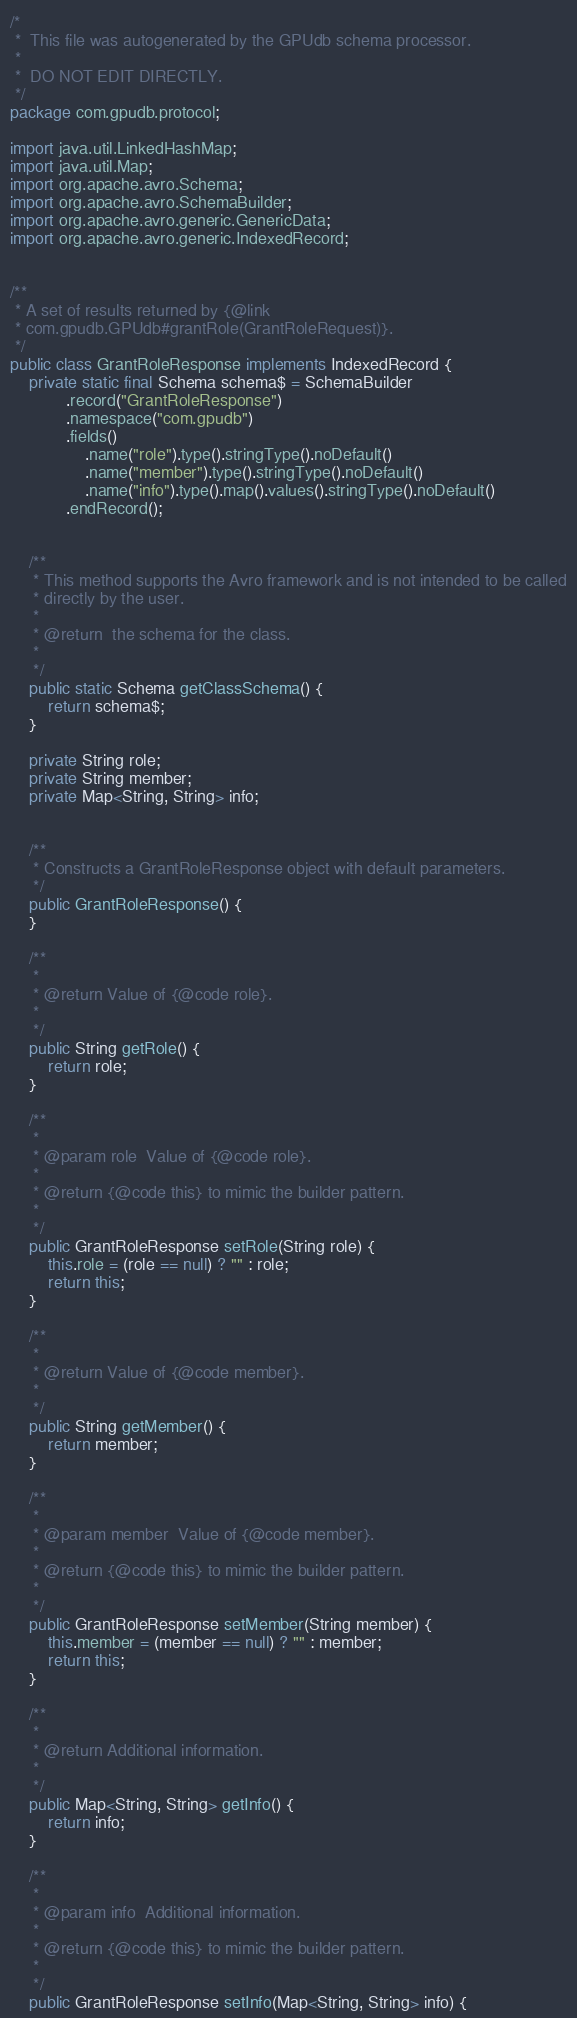Convert code to text. <code><loc_0><loc_0><loc_500><loc_500><_Java_>/*
 *  This file was autogenerated by the GPUdb schema processor.
 *
 *  DO NOT EDIT DIRECTLY.
 */
package com.gpudb.protocol;

import java.util.LinkedHashMap;
import java.util.Map;
import org.apache.avro.Schema;
import org.apache.avro.SchemaBuilder;
import org.apache.avro.generic.GenericData;
import org.apache.avro.generic.IndexedRecord;


/**
 * A set of results returned by {@link
 * com.gpudb.GPUdb#grantRole(GrantRoleRequest)}.
 */
public class GrantRoleResponse implements IndexedRecord {
    private static final Schema schema$ = SchemaBuilder
            .record("GrantRoleResponse")
            .namespace("com.gpudb")
            .fields()
                .name("role").type().stringType().noDefault()
                .name("member").type().stringType().noDefault()
                .name("info").type().map().values().stringType().noDefault()
            .endRecord();


    /**
     * This method supports the Avro framework and is not intended to be called
     * directly by the user.
     * 
     * @return  the schema for the class.
     * 
     */
    public static Schema getClassSchema() {
        return schema$;
    }

    private String role;
    private String member;
    private Map<String, String> info;


    /**
     * Constructs a GrantRoleResponse object with default parameters.
     */
    public GrantRoleResponse() {
    }

    /**
     * 
     * @return Value of {@code role}.
     * 
     */
    public String getRole() {
        return role;
    }

    /**
     * 
     * @param role  Value of {@code role}.
     * 
     * @return {@code this} to mimic the builder pattern.
     * 
     */
    public GrantRoleResponse setRole(String role) {
        this.role = (role == null) ? "" : role;
        return this;
    }

    /**
     * 
     * @return Value of {@code member}.
     * 
     */
    public String getMember() {
        return member;
    }

    /**
     * 
     * @param member  Value of {@code member}.
     * 
     * @return {@code this} to mimic the builder pattern.
     * 
     */
    public GrantRoleResponse setMember(String member) {
        this.member = (member == null) ? "" : member;
        return this;
    }

    /**
     * 
     * @return Additional information.
     * 
     */
    public Map<String, String> getInfo() {
        return info;
    }

    /**
     * 
     * @param info  Additional information.
     * 
     * @return {@code this} to mimic the builder pattern.
     * 
     */
    public GrantRoleResponse setInfo(Map<String, String> info) {</code> 